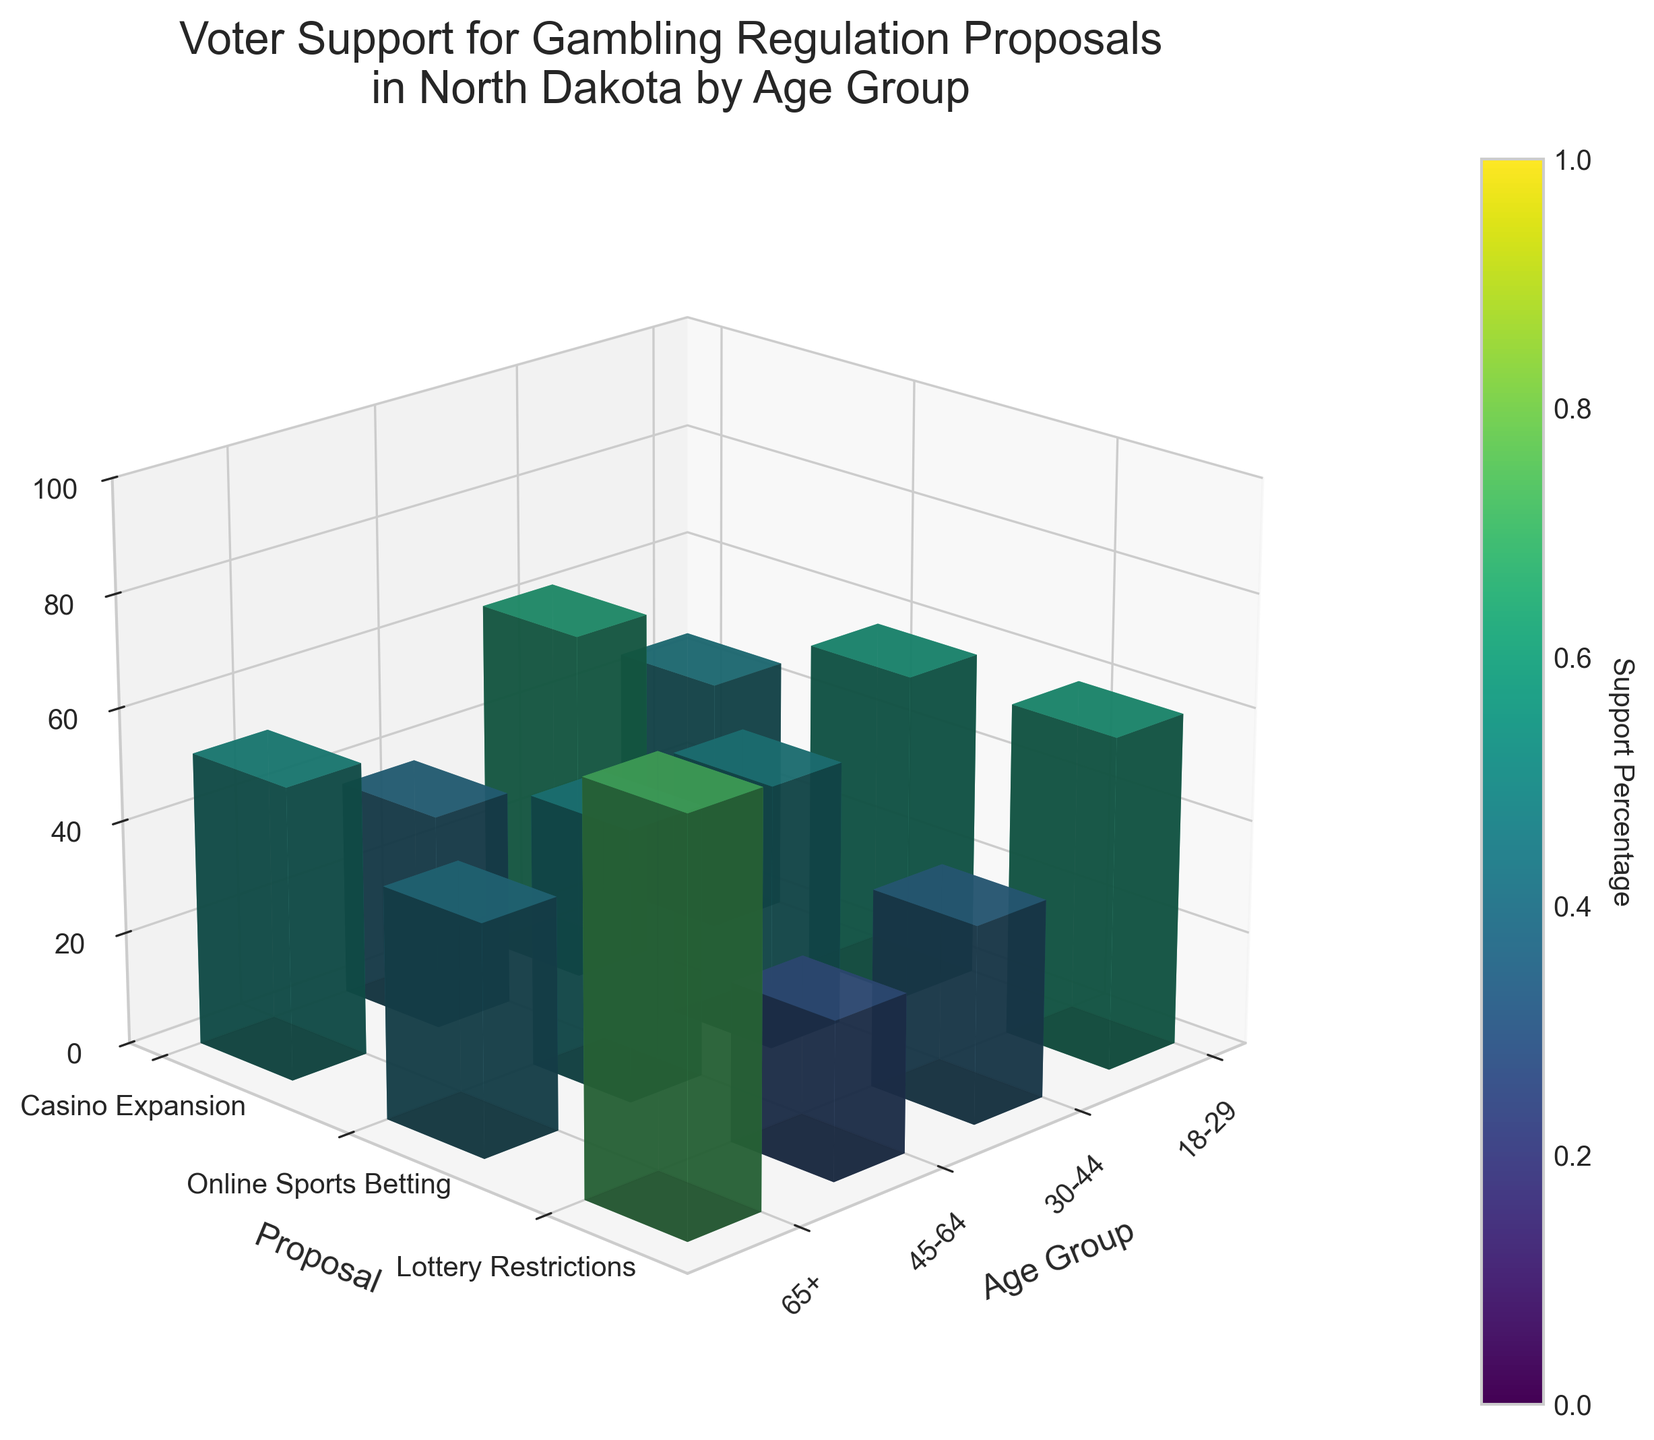How many age groups are represented in the data? The plot categorizes data across different age groups. To determine how many there are, look at the x-axis.
Answer: 4 Which proposal has the least support among voters aged 65+? Find the bar heights in the "65+" column and identify the shortest one.
Answer: Online Sports Betting What is the overall trend in support for Lottery Restrictions as age increases? Observe the height of the bars for Lottery Restrictions across age groups from 18-29 to 65+.
Answer: Increases Among voters aged 18-29, which proposal has the highest support? Look at the bars for the 18-29 column and find the tallest bar.
Answer: Online Sports Betting By how much does support for Casino Expansion differ between voters aged 30-44 and those aged 45-64? Compare the bar heights for Casino Expansion in the 30-44 and 45-64 age groups and calculate the difference.
Answer: 4% How does support for Online Sports Betting in the 30-44 age group compare to the 18-29 age group? Compare the heights of the bars for Online Sports Betting between the 30-44 and 18-29 age groups.
Answer: 4% less What is the average support for Online Sports Betting across all age groups? Sum the support percentages for Online Sports Betting across all age groups and divide by the number of age groups. ((62 + 58 + 41 + 28) / 4 = 47.25)
Answer: 47.25% Is there any age group where Casino Expansion has more support than Online Sports Betting? For each age group, compare the bar heights for Casino Expansion and Online Sports Betting.
Answer: No What is the color gradient indicating in the figure? The color gradient in the bar plot represents support percentages, where colors closer to yellow indicate higher support and those closer to purple indicate lower support.
Answer: Support Percentage In which age group is support for Lottery Restrictions the highest? Observe the highest bar for Lottery Restrictions across all age groups.
Answer: 65+ 